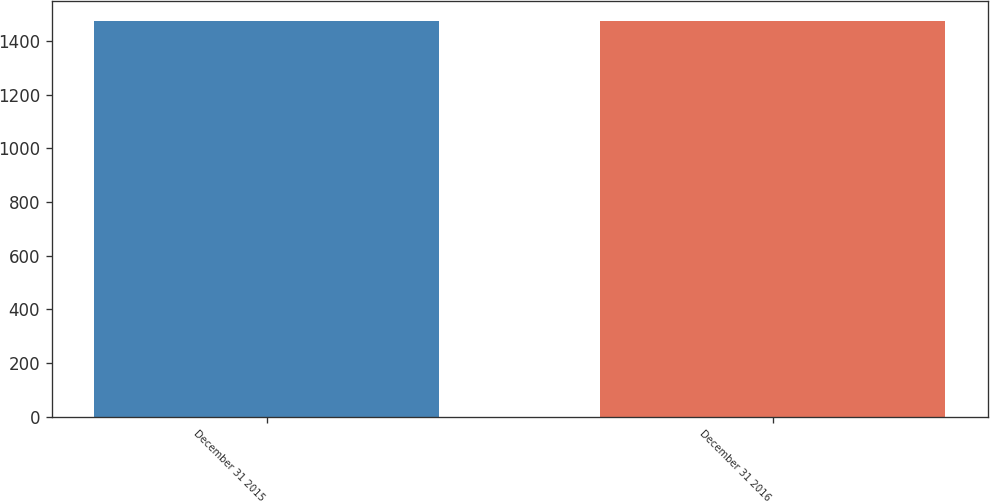Convert chart. <chart><loc_0><loc_0><loc_500><loc_500><bar_chart><fcel>December 31 2015<fcel>December 31 2016<nl><fcel>1475<fcel>1475.1<nl></chart> 